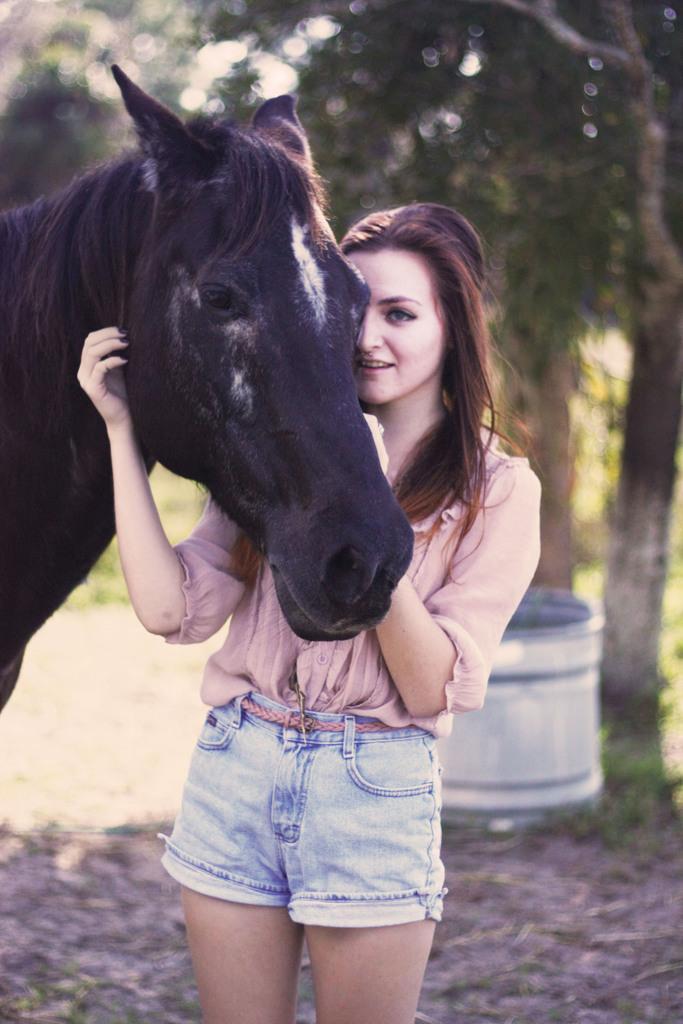Describe this image in one or two sentences. In this image we can see a lady wearing pink shirt is touching the horse. In the background of the image we can see trees. 